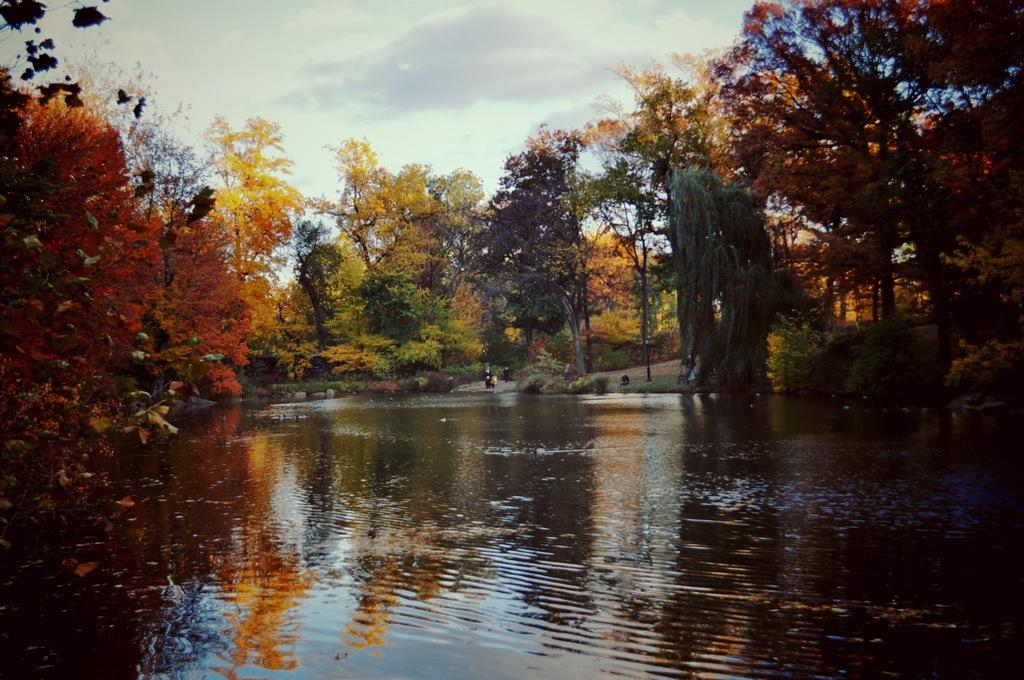What is at the bottom of the image? There is water at the bottom of the image. What can be seen on either side of the water? There are trees on either side of the water. What is visible at the top of the image? The sky is visible at the top of the image. Where are the people located in the image? The people are on the land on the right side of the image. What type of health services are available in the image? There is no indication of health services in the image; it primarily features water, trees, sky, and people. Can you tell me where the police station is located in the image? There is no police station present in the image. 